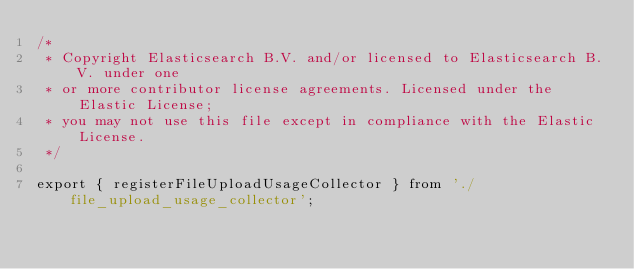Convert code to text. <code><loc_0><loc_0><loc_500><loc_500><_TypeScript_>/*
 * Copyright Elasticsearch B.V. and/or licensed to Elasticsearch B.V. under one
 * or more contributor license agreements. Licensed under the Elastic License;
 * you may not use this file except in compliance with the Elastic License.
 */

export { registerFileUploadUsageCollector } from './file_upload_usage_collector';
</code> 